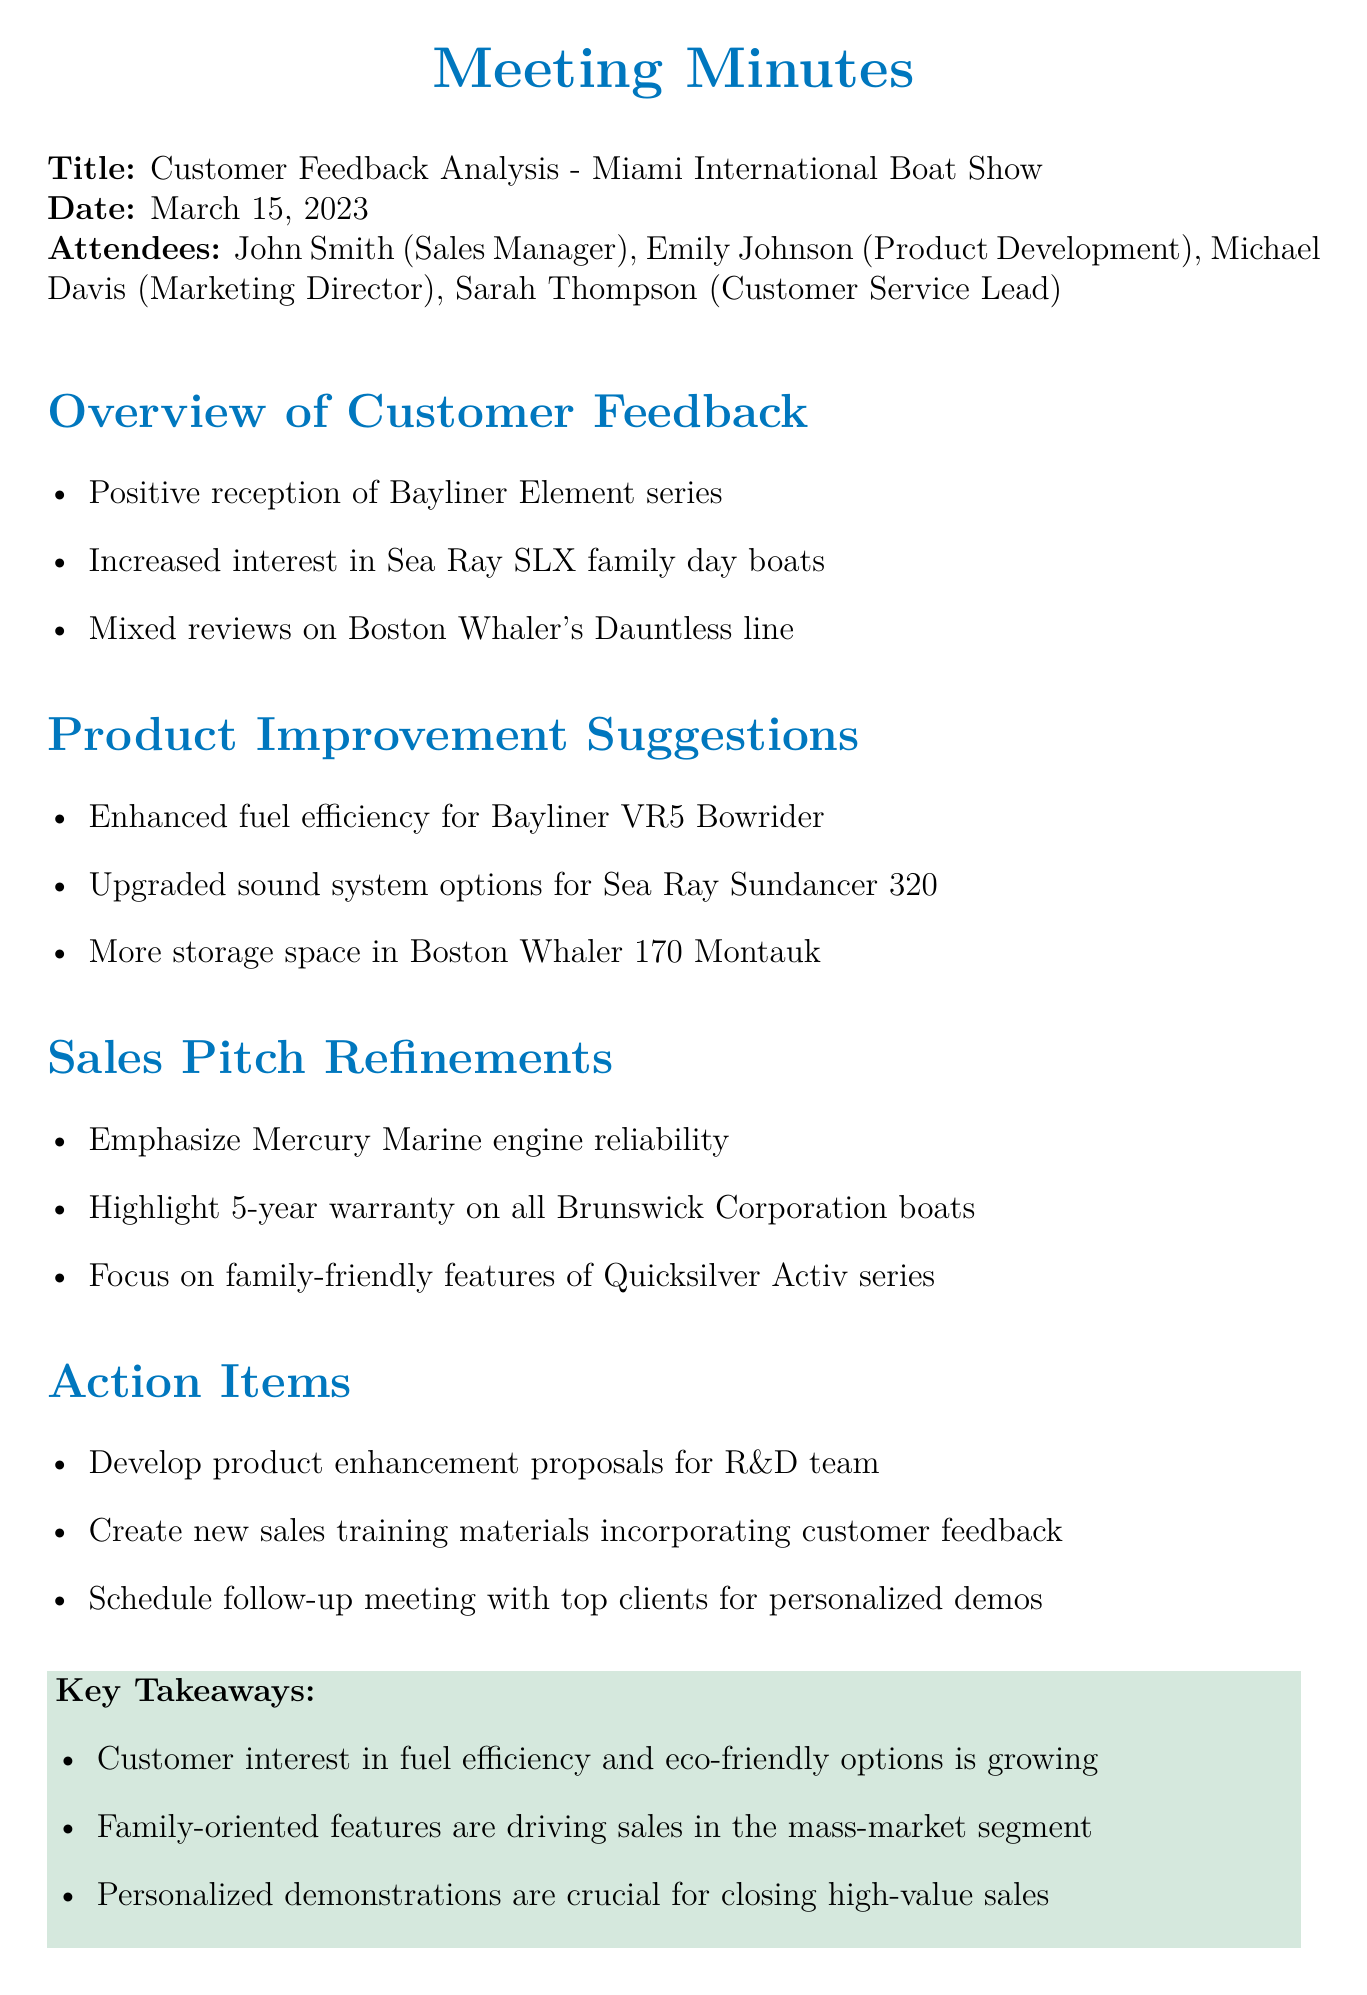what was the meeting title? The meeting title is the first piece of information provided in the document.
Answer: Customer Feedback Analysis - Miami International Boat Show who attended the meeting? The attendees are listed immediately after the meeting title and date.
Answer: John Smith, Emily Johnson, Michael Davis, Sarah Thompson what date was the meeting held? The date is explicitly stated following the meeting title.
Answer: March 15, 2023 what was a key takeaway regarding customer preferences? The takeaways summarize significant insights from the feedback, specifically preferences noted in the meeting.
Answer: Customer interest in fuel efficiency and eco-friendly options is growing which product's fuel efficiency was suggested for enhancement? The suggestion relates to specific products discussed under the Product Improvement Suggestions section.
Answer: Bayliner VR5 Bowrider what warranty feature should be highlighted in sales pitches? This is mentioned explicitly in the Sales Pitch Refinements section.
Answer: 5-year warranty on all Brunswick Corporation boats what is the primary focus for the Quicksilver Activ series in sales pitches? This information is found in the Sales Pitch Refinements, emphasizing selling points.
Answer: Family-friendly features how many attendees were present at the meeting? The total number of attendees can be counted from the names listed in the document.
Answer: 4 what action item involves developing proposals? This detail can be found in the Action Items section, indicating the focus on product enhancement.
Answer: Develop product enhancement proposals for R&D team 